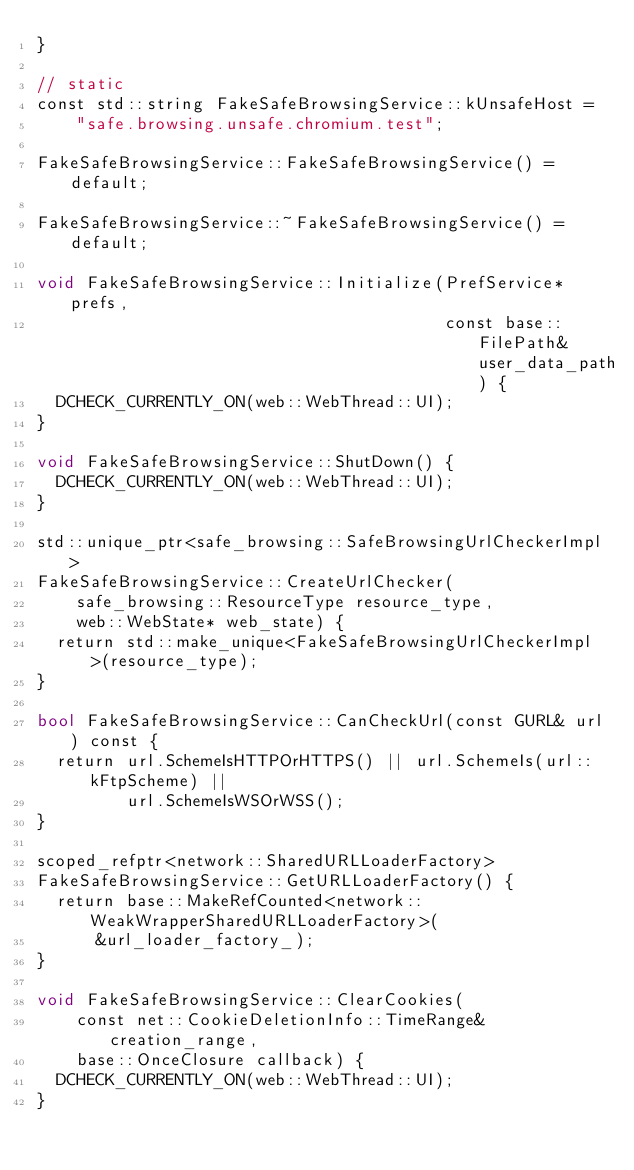Convert code to text. <code><loc_0><loc_0><loc_500><loc_500><_ObjectiveC_>}

// static
const std::string FakeSafeBrowsingService::kUnsafeHost =
    "safe.browsing.unsafe.chromium.test";

FakeSafeBrowsingService::FakeSafeBrowsingService() = default;

FakeSafeBrowsingService::~FakeSafeBrowsingService() = default;

void FakeSafeBrowsingService::Initialize(PrefService* prefs,
                                         const base::FilePath& user_data_path) {
  DCHECK_CURRENTLY_ON(web::WebThread::UI);
}

void FakeSafeBrowsingService::ShutDown() {
  DCHECK_CURRENTLY_ON(web::WebThread::UI);
}

std::unique_ptr<safe_browsing::SafeBrowsingUrlCheckerImpl>
FakeSafeBrowsingService::CreateUrlChecker(
    safe_browsing::ResourceType resource_type,
    web::WebState* web_state) {
  return std::make_unique<FakeSafeBrowsingUrlCheckerImpl>(resource_type);
}

bool FakeSafeBrowsingService::CanCheckUrl(const GURL& url) const {
  return url.SchemeIsHTTPOrHTTPS() || url.SchemeIs(url::kFtpScheme) ||
         url.SchemeIsWSOrWSS();
}

scoped_refptr<network::SharedURLLoaderFactory>
FakeSafeBrowsingService::GetURLLoaderFactory() {
  return base::MakeRefCounted<network::WeakWrapperSharedURLLoaderFactory>(
      &url_loader_factory_);
}

void FakeSafeBrowsingService::ClearCookies(
    const net::CookieDeletionInfo::TimeRange& creation_range,
    base::OnceClosure callback) {
  DCHECK_CURRENTLY_ON(web::WebThread::UI);
}
</code> 